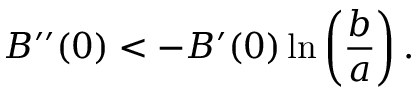<formula> <loc_0><loc_0><loc_500><loc_500>B ^ { \prime \prime } ( 0 ) < - B ^ { \prime } ( 0 ) \ln \left ( \frac { b } { a } \right ) .</formula> 